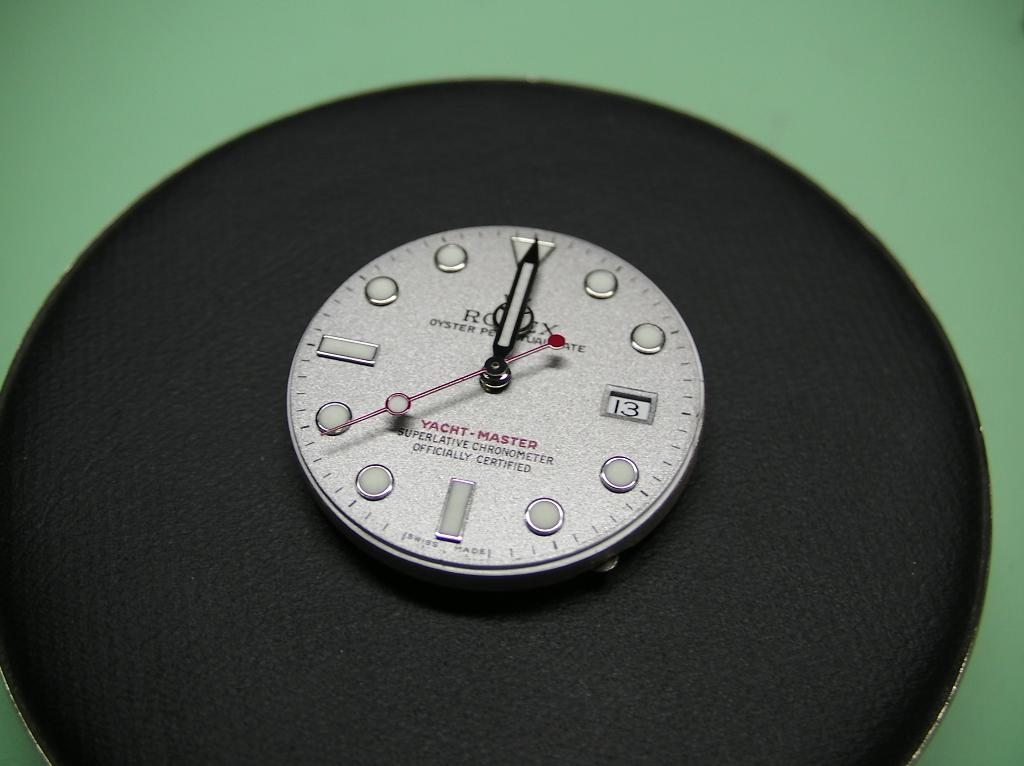<image>
Offer a succinct explanation of the picture presented. A round Yacht Master Superlative Chronometer sitting on a black surface 